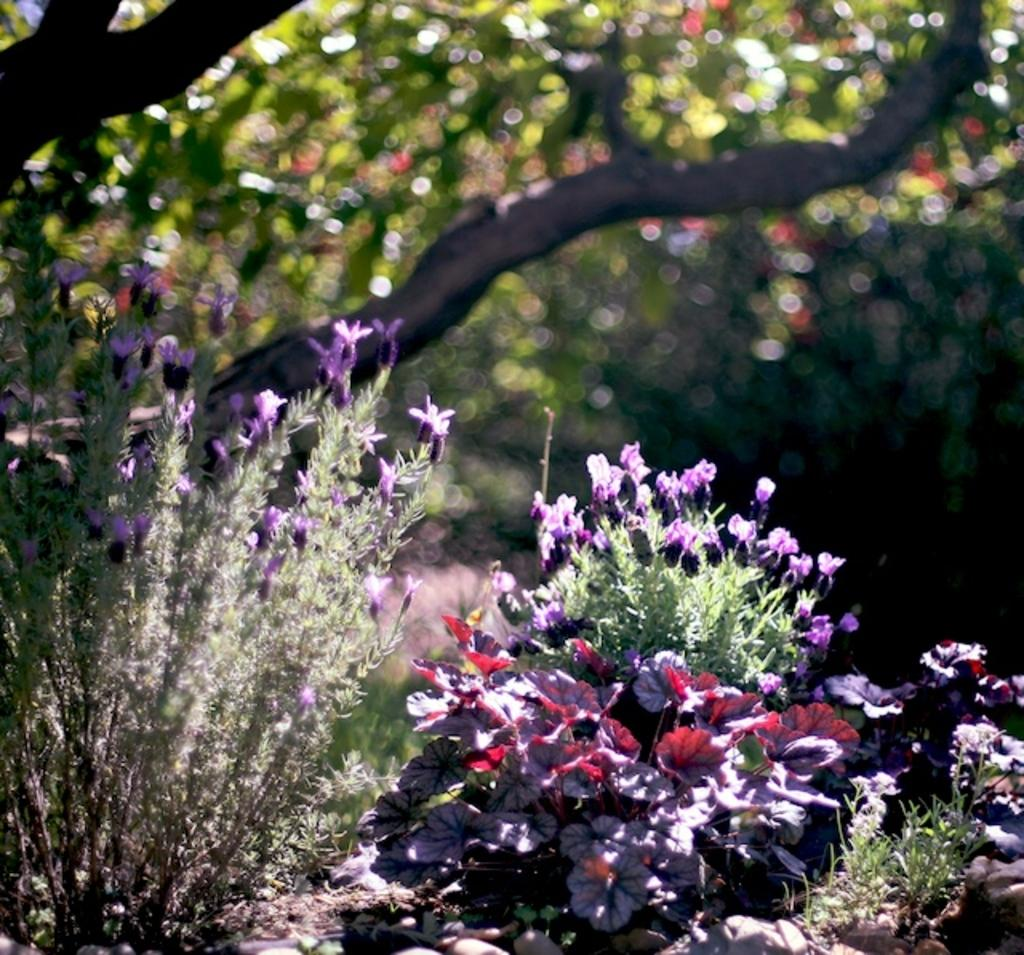What type of flora can be seen in the image? There is a group of flowers and plants in the image. What other type of plant is present in the image? There is a tree in the image. How would you describe the background of the image? The background of the image is blurred. What color is the gold stocking hanging from the tree in the image? There is no gold stocking present in the image; it only features flowers, plants, and a tree. 